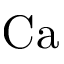Convert formula to latex. <formula><loc_0><loc_0><loc_500><loc_500>C a</formula> 